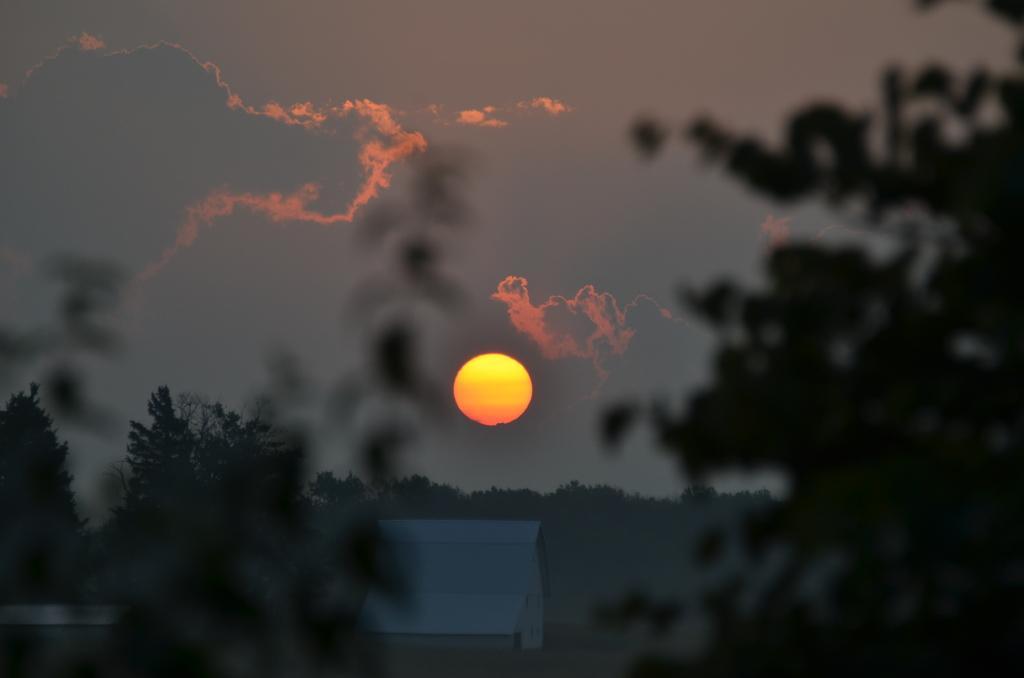Describe this image in one or two sentences. In this picture we can see a house. There are a few trees visible from left to right. We can see the sun in the sky. Sky is cloudy. 